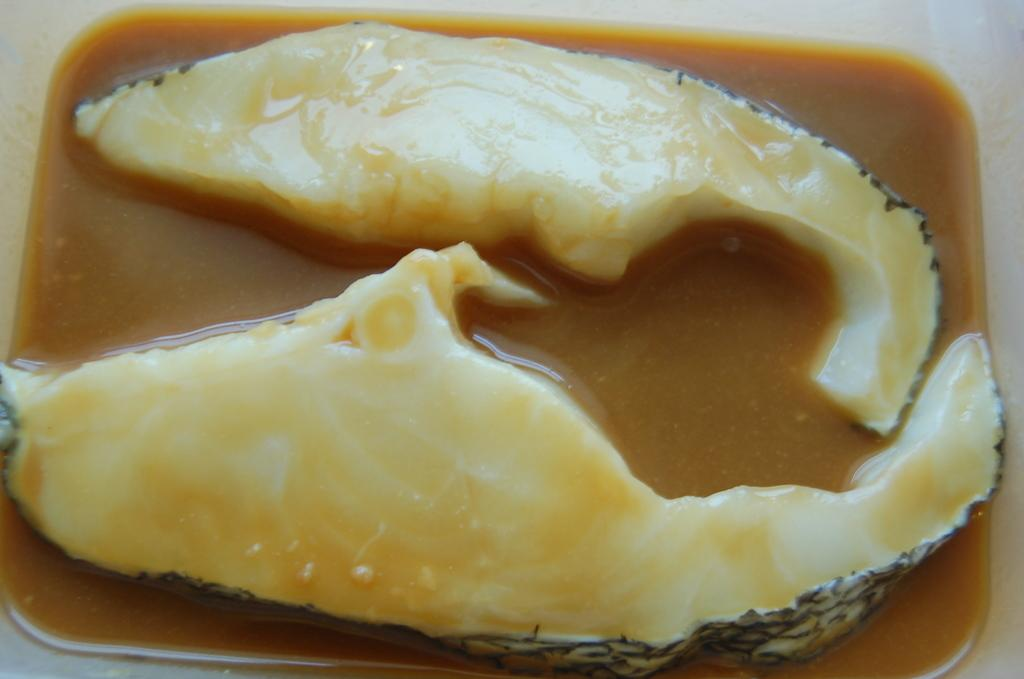What color is the bowl in the image? The bowl in the image is white colored. What is inside the bowl? There is a brown soup in the bowl. Can you describe the contents of the soup? The soup contains two fish pieces, and they are cream in color. What is the value of the fish pieces in the image? There is no value assigned to the fish pieces in the image; they are simply part of the soup. 